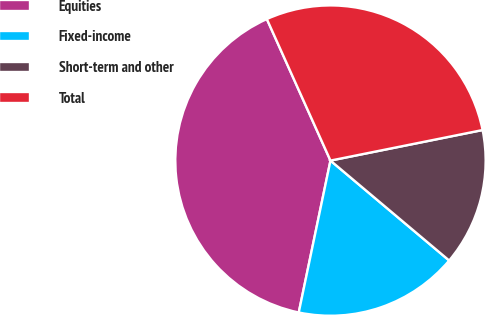Convert chart. <chart><loc_0><loc_0><loc_500><loc_500><pie_chart><fcel>Equities<fcel>Fixed-income<fcel>Short-term and other<fcel>Total<nl><fcel>40.0%<fcel>17.14%<fcel>14.29%<fcel>28.57%<nl></chart> 